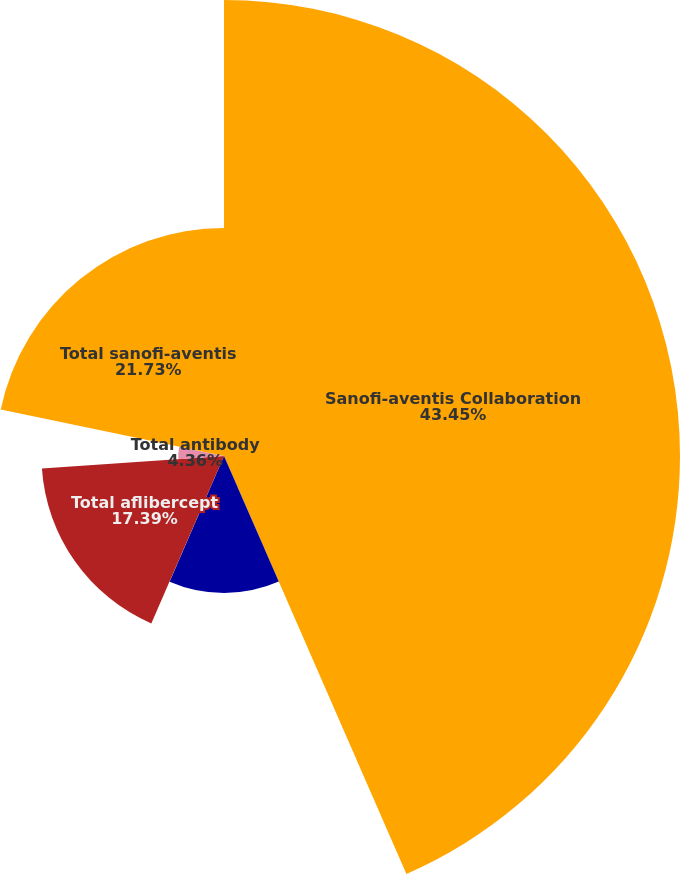Convert chart to OTSL. <chart><loc_0><loc_0><loc_500><loc_500><pie_chart><fcel>Sanofi-aventis Collaboration<fcel>Regeneron expense<fcel>Recognition of deferred<fcel>Total aflibercept<fcel>Total antibody<fcel>Total sanofi-aventis<nl><fcel>43.45%<fcel>13.05%<fcel>0.02%<fcel>17.39%<fcel>4.36%<fcel>21.73%<nl></chart> 